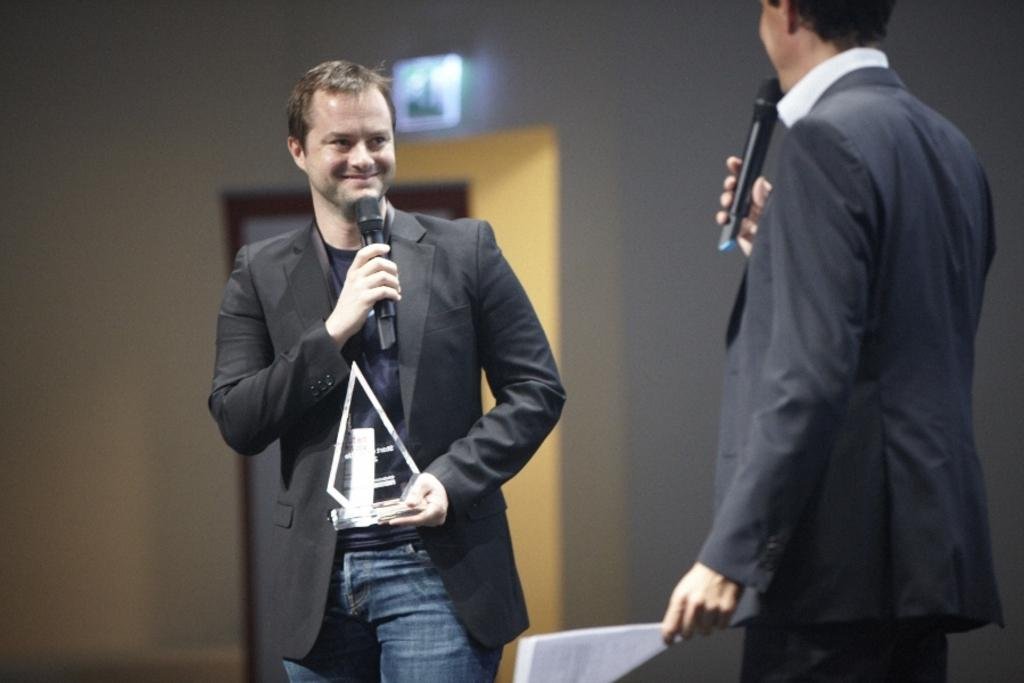What is the person in the image holding? The person is holding a mic, an award, and papers. What might the person be doing with the mic? The person might be using the mic to speak or make an announcement. What is on the wall in the background of the image? There is a board on the wall in the background of the image. What type of collar can be seen on the person in the image? There is no collar visible on the person in the image. What attraction is the person visiting in the image? There is no indication of an attraction in the image; it only shows a person holding a mic, an award, and papers. 